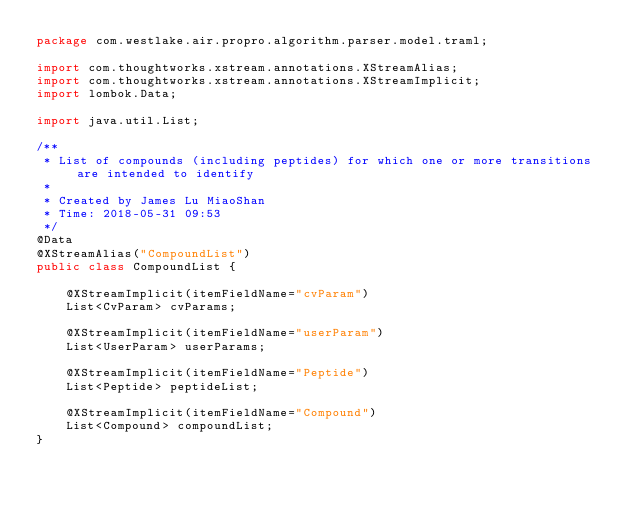<code> <loc_0><loc_0><loc_500><loc_500><_Java_>package com.westlake.air.propro.algorithm.parser.model.traml;

import com.thoughtworks.xstream.annotations.XStreamAlias;
import com.thoughtworks.xstream.annotations.XStreamImplicit;
import lombok.Data;

import java.util.List;

/**
 * List of compounds (including peptides) for which one or more transitions are intended to identify
 *
 * Created by James Lu MiaoShan
 * Time: 2018-05-31 09:53
 */
@Data
@XStreamAlias("CompoundList")
public class CompoundList {

    @XStreamImplicit(itemFieldName="cvParam")
    List<CvParam> cvParams;

    @XStreamImplicit(itemFieldName="userParam")
    List<UserParam> userParams;

    @XStreamImplicit(itemFieldName="Peptide")
    List<Peptide> peptideList;

    @XStreamImplicit(itemFieldName="Compound")
    List<Compound> compoundList;
}
</code> 